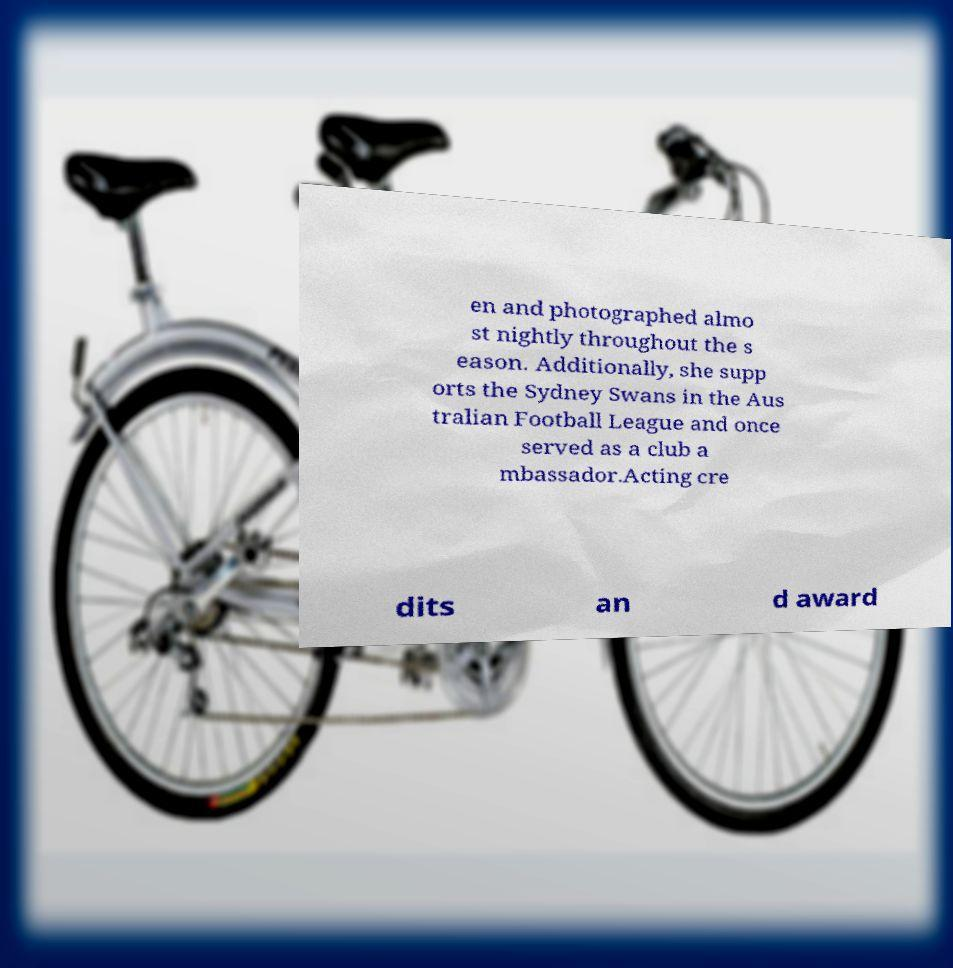Can you read and provide the text displayed in the image?This photo seems to have some interesting text. Can you extract and type it out for me? en and photographed almo st nightly throughout the s eason. Additionally, she supp orts the Sydney Swans in the Aus tralian Football League and once served as a club a mbassador.Acting cre dits an d award 